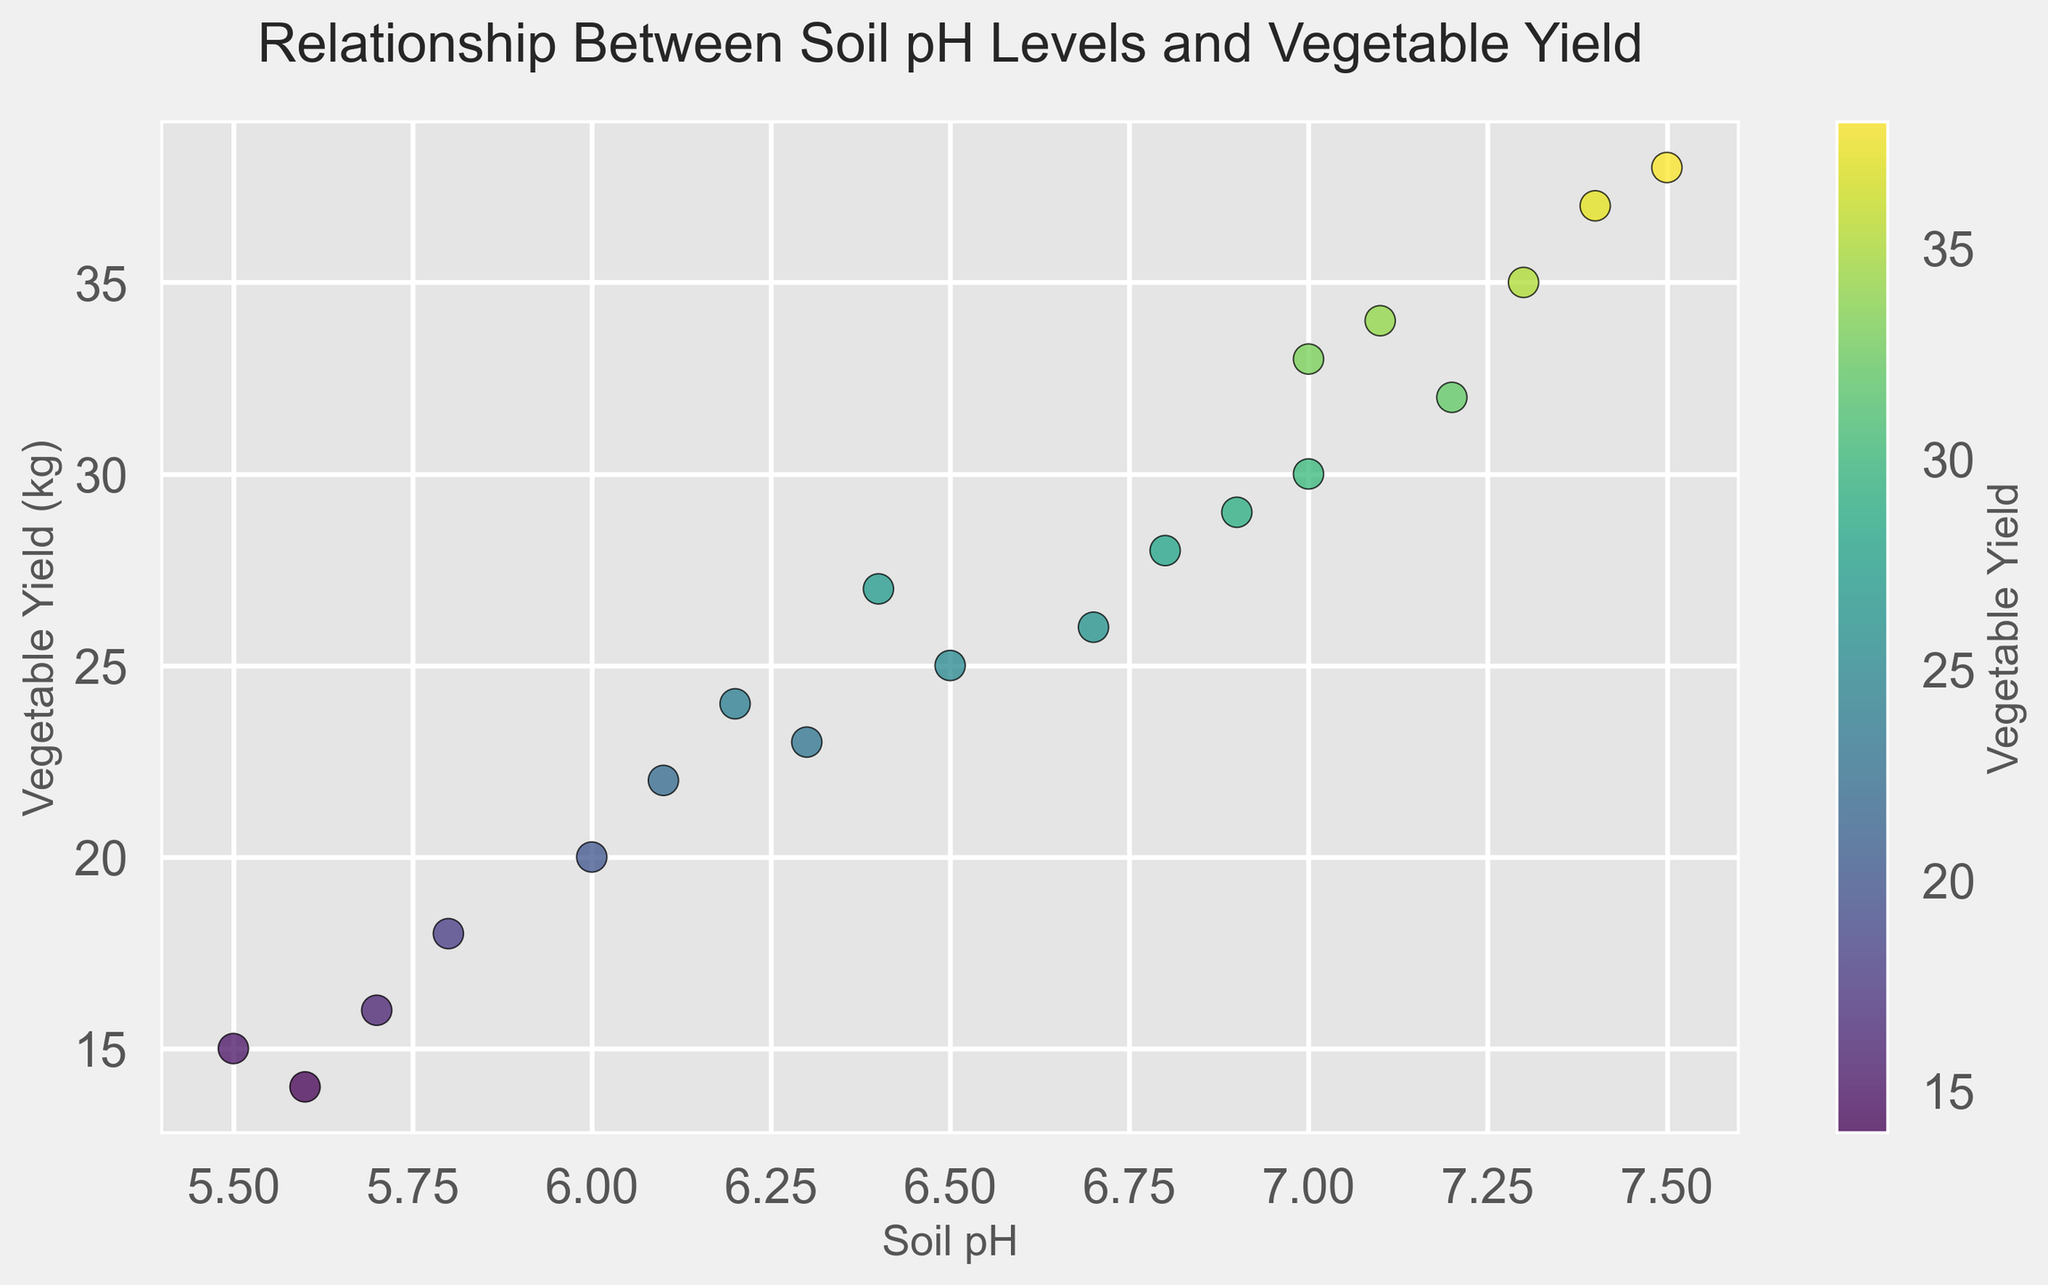what is the range of soil pH levels observed in the garden plots? The range of soil pH levels is the difference between the highest and lowest soil pH values in the data. The highest pH level is 7.5, and the lowest is 5.5. The range is 7.5 - 5.5.
Answer: 2.0 Which garden plot has the highest vegetable yield? By looking at the scatter plot, we observe which data point is at the highest position along the vegetable yield axis. The plot with the highest vegetable yield of 38 belongs to garden plot 9.
Answer: Garden plot 9 What is the average vegetable yield for garden plots with a soil pH of 7.0? There are two garden plots with a soil pH of 7.0 (plots 2 and 18). Their yields are 30 and 33. To find the average, sum these yields and divide by the number of plots: (30 + 33) / 2 = 31.5.
Answer: 31.5 How does vegetable yield change with increasing soil pH? Generally, by examining the scatter plot, there is a tendency for vegetable yield to increase as soil pH increases, as indicated by the upward trend of points.
Answer: Increases Are there any garden plots with the same vegetable yield but different soil pH levels? By inspecting the scatter plot visually, we can identify if any points are horizontally aligned but with different soil pH levels. For example, the yield of 20 is seen in plots 6.0 and 6.1, but these have different pH levels.
Answer: Yes What is the difference in vegetable yield between the garden plot with the highest pH and the garden plot with the lowest pH? The plot with the highest pH (7.5, garden plot 9) has a yield of 38. The plot with the lowest pH (5.5, garden plot 3) has a yield of 15. The difference is 38 - 15.
Answer: 23 Which garden plot has the lowest soil pH, and what is its vegetable yield? By looking at the scatter plot, we locate the point with the smallest soil pH value. Garden plot 3 with a soil pH of 5.5 has a vegetable yield of 15.
Answer: Garden plot 3, 15 How many garden plots have a soil pH greater than 7.0? We count the number of points on the scatter plot with soil pH values greater than 7.0. From the data, garden plots with pH values greater than 7.0 are 5, 8, 9, 12, 16. There are 5 such plots.
Answer: 5 Is there a significant difference in vegetable yield between garden plots with pH levels of 6.2 and 6.8? By comparing the data points at pH levels of 6.2 (24) and 6.8 (28), the vegetable yield difference is 28 - 24 = 4. This is not a large difference in the context of other variations observed in the plot.
Answer: No 